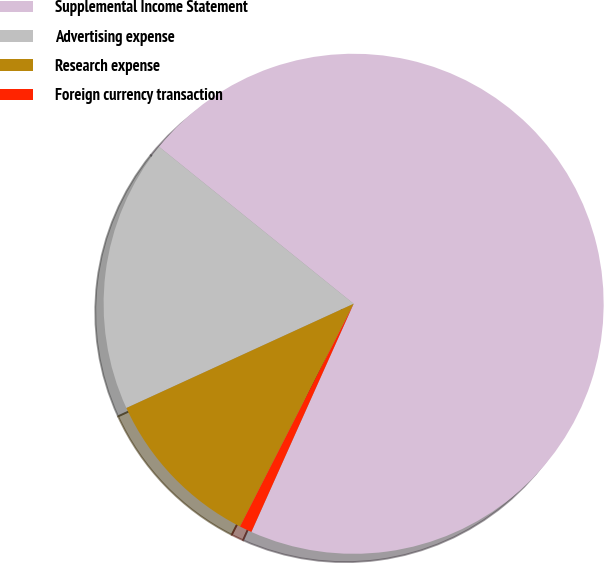Convert chart. <chart><loc_0><loc_0><loc_500><loc_500><pie_chart><fcel>Supplemental Income Statement<fcel>Advertising expense<fcel>Research expense<fcel>Foreign currency transaction<nl><fcel>70.9%<fcel>17.65%<fcel>10.65%<fcel>0.8%<nl></chart> 